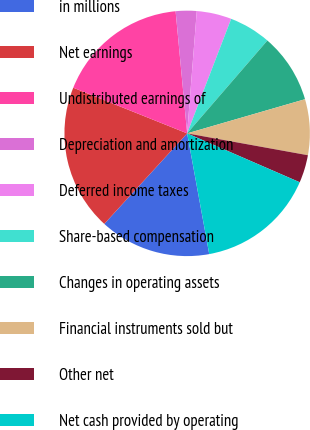Convert chart. <chart><loc_0><loc_0><loc_500><loc_500><pie_chart><fcel>in millions<fcel>Net earnings<fcel>Undistributed earnings of<fcel>Depreciation and amortization<fcel>Deferred income taxes<fcel>Share-based compensation<fcel>Changes in operating assets<fcel>Financial instruments sold but<fcel>Other net<fcel>Net cash provided by operating<nl><fcel>14.68%<fcel>19.27%<fcel>17.43%<fcel>2.75%<fcel>4.59%<fcel>5.5%<fcel>9.17%<fcel>7.34%<fcel>3.67%<fcel>15.6%<nl></chart> 